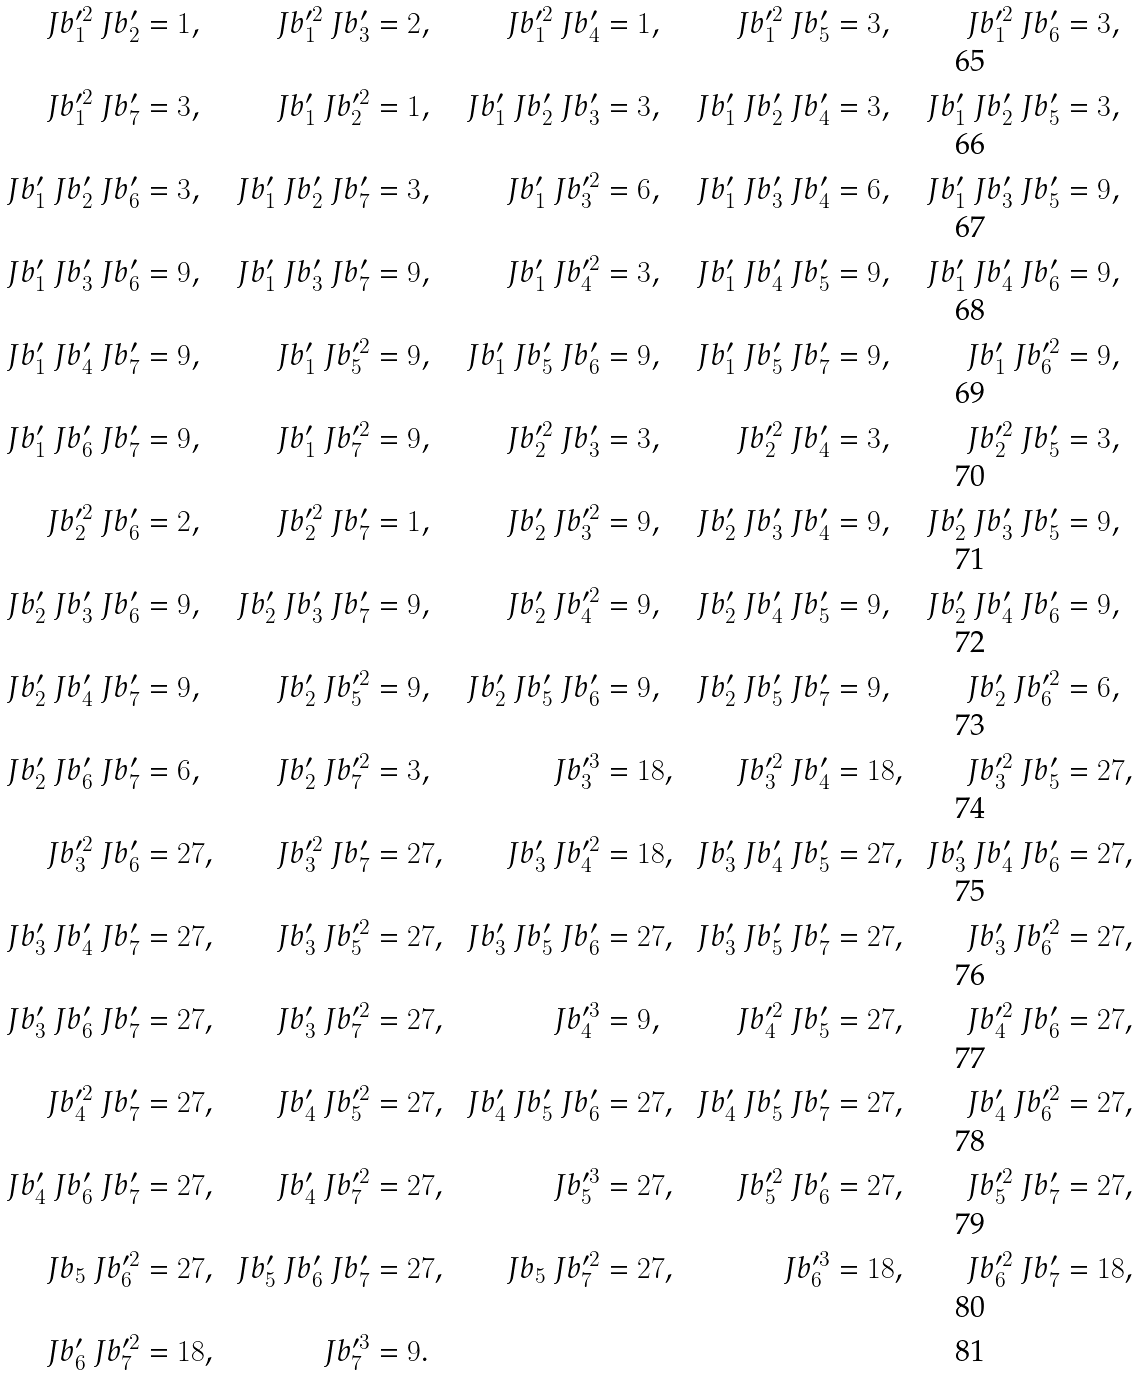<formula> <loc_0><loc_0><loc_500><loc_500>\ J b _ { 1 } ^ { \prime 2 } \ J b _ { 2 } ^ { \prime } & = 1 , & \ J b _ { 1 } ^ { \prime 2 } \ J b _ { 3 } ^ { \prime } & = 2 , & \ J b _ { 1 } ^ { \prime 2 } \ J b _ { 4 } ^ { \prime } & = 1 , & \ J b _ { 1 } ^ { \prime 2 } \ J b _ { 5 } ^ { \prime } & = 3 , & \ J b _ { 1 } ^ { \prime 2 } \ J b _ { 6 } ^ { \prime } & = 3 , \\ \ J b _ { 1 } ^ { \prime 2 } \ J b _ { 7 } ^ { \prime } & = 3 , & \ J b _ { 1 } ^ { \prime } \ J b _ { 2 } ^ { \prime 2 } & = 1 , & \ J b _ { 1 } ^ { \prime } \ J b _ { 2 } ^ { \prime } \ J b _ { 3 } ^ { \prime } & = 3 , & \ J b _ { 1 } ^ { \prime } \ J b _ { 2 } ^ { \prime } \ J b _ { 4 } ^ { \prime } & = 3 , & \ J b _ { 1 } ^ { \prime } \ J b _ { 2 } ^ { \prime } \ J b _ { 5 } ^ { \prime } & = 3 , \\ \ J b _ { 1 } ^ { \prime } \ J b _ { 2 } ^ { \prime } \ J b _ { 6 } ^ { \prime } & = 3 , & \ J b _ { 1 } ^ { \prime } \ J b _ { 2 } ^ { \prime } \ J b _ { 7 } ^ { \prime } & = 3 , & \ J b _ { 1 } ^ { \prime } \ J b _ { 3 } ^ { \prime 2 } & = 6 , & \ J b _ { 1 } ^ { \prime } \ J b _ { 3 } ^ { \prime } \ J b _ { 4 } ^ { \prime } & = 6 , & \ J b _ { 1 } ^ { \prime } \ J b _ { 3 } ^ { \prime } \ J b _ { 5 } ^ { \prime } & = 9 , \\ \ J b _ { 1 } ^ { \prime } \ J b _ { 3 } ^ { \prime } \ J b _ { 6 } ^ { \prime } & = 9 , & \ J b _ { 1 } ^ { \prime } \ J b _ { 3 } ^ { \prime } \ J b _ { 7 } ^ { \prime } & = 9 , & \ J b _ { 1 } ^ { \prime } \ J b _ { 4 } ^ { \prime 2 } & = 3 , & \ J b _ { 1 } ^ { \prime } \ J b _ { 4 } ^ { \prime } \ J b _ { 5 } ^ { \prime } & = 9 , & \ J b _ { 1 } ^ { \prime } \ J b _ { 4 } ^ { \prime } \ J b _ { 6 } ^ { \prime } & = 9 , \\ \ J b _ { 1 } ^ { \prime } \ J b _ { 4 } ^ { \prime } \ J b _ { 7 } ^ { \prime } & = 9 , & \ J b _ { 1 } ^ { \prime } \ J b _ { 5 } ^ { \prime 2 } & = 9 , & \ J b _ { 1 } ^ { \prime } \ J b _ { 5 } ^ { \prime } \ J b _ { 6 } ^ { \prime } & = 9 , & \ J b _ { 1 } ^ { \prime } \ J b _ { 5 } ^ { \prime } \ J b _ { 7 } ^ { \prime } & = 9 , & \ J b _ { 1 } ^ { \prime } \ J b _ { 6 } ^ { \prime 2 } & = 9 , \\ \ J b _ { 1 } ^ { \prime } \ J b _ { 6 } ^ { \prime } \ J b _ { 7 } ^ { \prime } & = 9 , & \ J b _ { 1 } ^ { \prime } \ J b _ { 7 } ^ { \prime 2 } & = 9 , & \ J b _ { 2 } ^ { \prime 2 } \ J b _ { 3 } ^ { \prime } & = 3 , & \ J b _ { 2 } ^ { \prime 2 } \ J b _ { 4 } ^ { \prime } & = 3 , & \ J b _ { 2 } ^ { \prime 2 } \ J b _ { 5 } ^ { \prime } & = 3 , \\ \ J b _ { 2 } ^ { \prime 2 } \ J b _ { 6 } ^ { \prime } & = 2 , & \ J b _ { 2 } ^ { \prime 2 } \ J b _ { 7 } ^ { \prime } & = 1 , & \ J b _ { 2 } ^ { \prime } \ J b _ { 3 } ^ { \prime 2 } & = 9 , & \ J b _ { 2 } ^ { \prime } \ J b _ { 3 } ^ { \prime } \ J b _ { 4 } ^ { \prime } & = 9 , & \ J b _ { 2 } ^ { \prime } \ J b _ { 3 } ^ { \prime } \ J b _ { 5 } ^ { \prime } & = 9 , \\ \ J b _ { 2 } ^ { \prime } \ J b _ { 3 } ^ { \prime } \ J b _ { 6 } ^ { \prime } & = 9 , & \ J b _ { 2 } ^ { \prime } \ J b _ { 3 } ^ { \prime } \ J b _ { 7 } ^ { \prime } & = 9 , & \ J b _ { 2 } ^ { \prime } \ J b _ { 4 } ^ { \prime 2 } & = 9 , & \ J b _ { 2 } ^ { \prime } \ J b _ { 4 } ^ { \prime } \ J b _ { 5 } ^ { \prime } & = 9 , & \ J b _ { 2 } ^ { \prime } \ J b _ { 4 } ^ { \prime } \ J b _ { 6 } ^ { \prime } & = 9 , \\ \ J b _ { 2 } ^ { \prime } \ J b _ { 4 } ^ { \prime } \ J b _ { 7 } ^ { \prime } & = 9 , & \ J b _ { 2 } ^ { \prime } \ J b _ { 5 } ^ { \prime 2 } & = 9 , & \ J b _ { 2 } ^ { \prime } \ J b _ { 5 } ^ { \prime } \ J b _ { 6 } ^ { \prime } & = 9 , & \ J b _ { 2 } ^ { \prime } \ J b _ { 5 } ^ { \prime } \ J b _ { 7 } ^ { \prime } & = 9 , & \ J b _ { 2 } ^ { \prime } \ J b _ { 6 } ^ { \prime 2 } & = 6 , \\ \ J b _ { 2 } ^ { \prime } \ J b _ { 6 } ^ { \prime } \ J b _ { 7 } ^ { \prime } & = 6 , & \ J b _ { 2 } ^ { \prime } \ J b _ { 7 } ^ { \prime 2 } & = 3 , & \ J b _ { 3 } ^ { \prime 3 } & = 1 8 , & \ J b _ { 3 } ^ { \prime 2 } \ J b _ { 4 } ^ { \prime } & = 1 8 , & \ J b _ { 3 } ^ { \prime 2 } \ J b _ { 5 } ^ { \prime } & = 2 7 , \\ \ J b _ { 3 } ^ { \prime 2 } \ J b _ { 6 } ^ { \prime } & = 2 7 , & \ J b _ { 3 } ^ { \prime 2 } \ J b _ { 7 } ^ { \prime } & = 2 7 , & \ J b _ { 3 } ^ { \prime } \ J b _ { 4 } ^ { \prime 2 } & = 1 8 , & \ J b _ { 3 } ^ { \prime } \ J b _ { 4 } ^ { \prime } \ J b _ { 5 } ^ { \prime } & = 2 7 , & \ J b _ { 3 } ^ { \prime } \ J b _ { 4 } ^ { \prime } \ J b _ { 6 } ^ { \prime } & = 2 7 , \\ \ J b _ { 3 } ^ { \prime } \ J b _ { 4 } ^ { \prime } \ J b _ { 7 } ^ { \prime } & = 2 7 , & \ J b _ { 3 } ^ { \prime } \ J b _ { 5 } ^ { \prime 2 } & = 2 7 , & \ J b _ { 3 } ^ { \prime } \ J b _ { 5 } ^ { \prime } \ J b _ { 6 } ^ { \prime } & = 2 7 , & \ J b _ { 3 } ^ { \prime } \ J b _ { 5 } ^ { \prime } \ J b _ { 7 } ^ { \prime } & = 2 7 , & \ J b _ { 3 } ^ { \prime } \ J b _ { 6 } ^ { \prime 2 } & = 2 7 , \\ \ J b _ { 3 } ^ { \prime } \ J b _ { 6 } ^ { \prime } \ J b _ { 7 } ^ { \prime } & = 2 7 , & \ J b _ { 3 } ^ { \prime } \ J b _ { 7 } ^ { \prime 2 } & = 2 7 , & \ J b _ { 4 } ^ { \prime 3 } & = 9 , & \ J b _ { 4 } ^ { \prime 2 } \ J b _ { 5 } ^ { \prime } & = 2 7 , & \ J b _ { 4 } ^ { \prime 2 } \ J b _ { 6 } ^ { \prime } & = 2 7 , \\ \ J b _ { 4 } ^ { \prime 2 } \ J b _ { 7 } ^ { \prime } & = 2 7 , & \ J b _ { 4 } ^ { \prime } \ J b _ { 5 } ^ { \prime 2 } & = 2 7 , & \ J b _ { 4 } ^ { \prime } \ J b _ { 5 } ^ { \prime } \ J b _ { 6 } ^ { \prime } & = 2 7 , & \ J b _ { 4 } ^ { \prime } \ J b _ { 5 } ^ { \prime } \ J b _ { 7 } ^ { \prime } & = 2 7 , & \ J b _ { 4 } ^ { \prime } \ J b _ { 6 } ^ { \prime 2 } & = 2 7 , \\ \ J b _ { 4 } ^ { \prime } \ J b _ { 6 } ^ { \prime } \ J b _ { 7 } ^ { \prime } & = 2 7 , & \ J b _ { 4 } ^ { \prime } \ J b _ { 7 } ^ { \prime 2 } & = 2 7 , & \ J b _ { 5 } ^ { \prime 3 } & = 2 7 , & \ J b _ { 5 } ^ { \prime 2 } \ J b _ { 6 } ^ { \prime } & = 2 7 , & \ J b _ { 5 } ^ { \prime 2 } \ J b _ { 7 } ^ { \prime } & = 2 7 , \\ \ J b _ { 5 } \ J b _ { 6 } ^ { \prime 2 } & = 2 7 , & \ J b _ { 5 } ^ { \prime } \ J b _ { 6 } ^ { \prime } \ J b _ { 7 } ^ { \prime } & = 2 7 , & \ J b _ { 5 } \ J b _ { 7 } ^ { \prime 2 } & = 2 7 , & \ J b _ { 6 } ^ { \prime 3 } & = 1 8 , & \ J b _ { 6 } ^ { \prime 2 } \ J b _ { 7 } ^ { \prime } & = 1 8 , \\ \ J b _ { 6 } ^ { \prime } \ J b _ { 7 } ^ { \prime 2 } & = 1 8 , & \ J b _ { 7 } ^ { \prime 3 } & = 9 .</formula> 